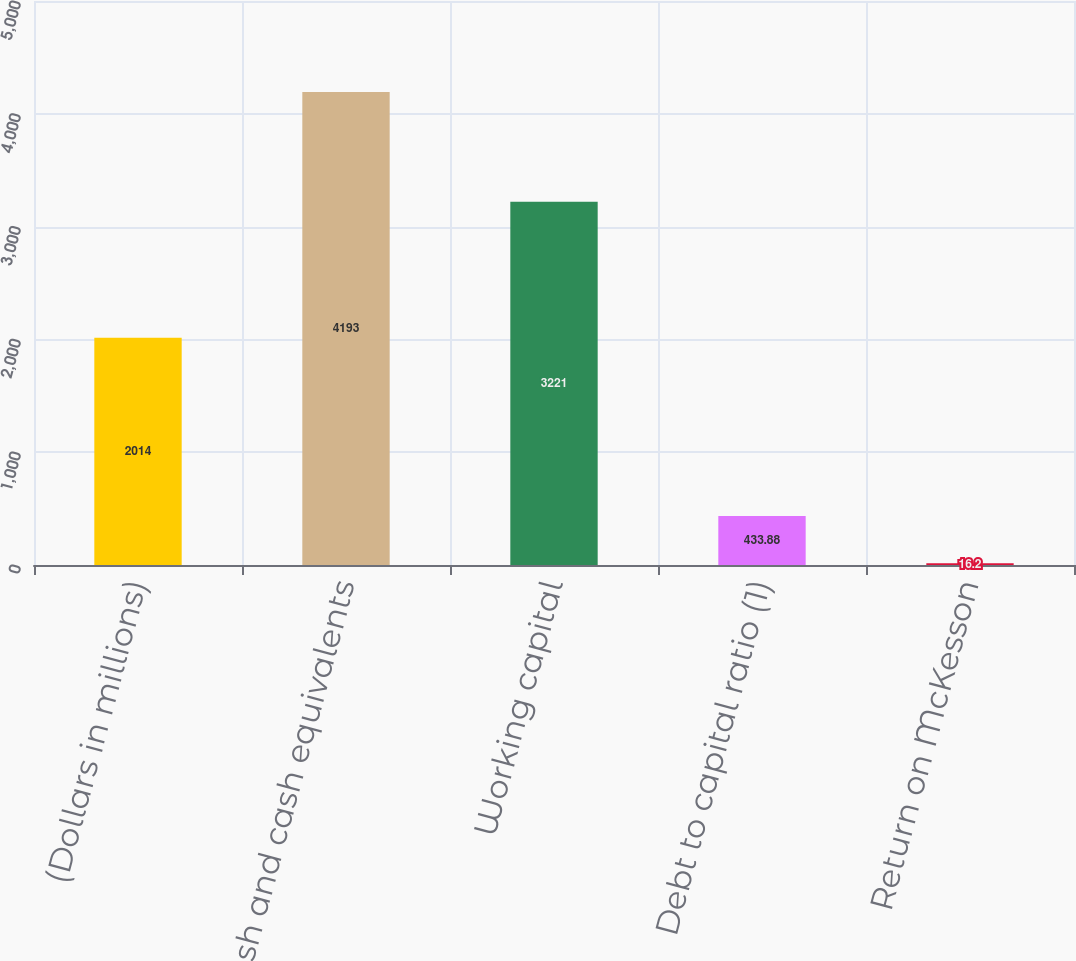Convert chart. <chart><loc_0><loc_0><loc_500><loc_500><bar_chart><fcel>(Dollars in millions)<fcel>Cash and cash equivalents<fcel>Working capital<fcel>Debt to capital ratio (1)<fcel>Return on McKesson<nl><fcel>2014<fcel>4193<fcel>3221<fcel>433.88<fcel>16.2<nl></chart> 